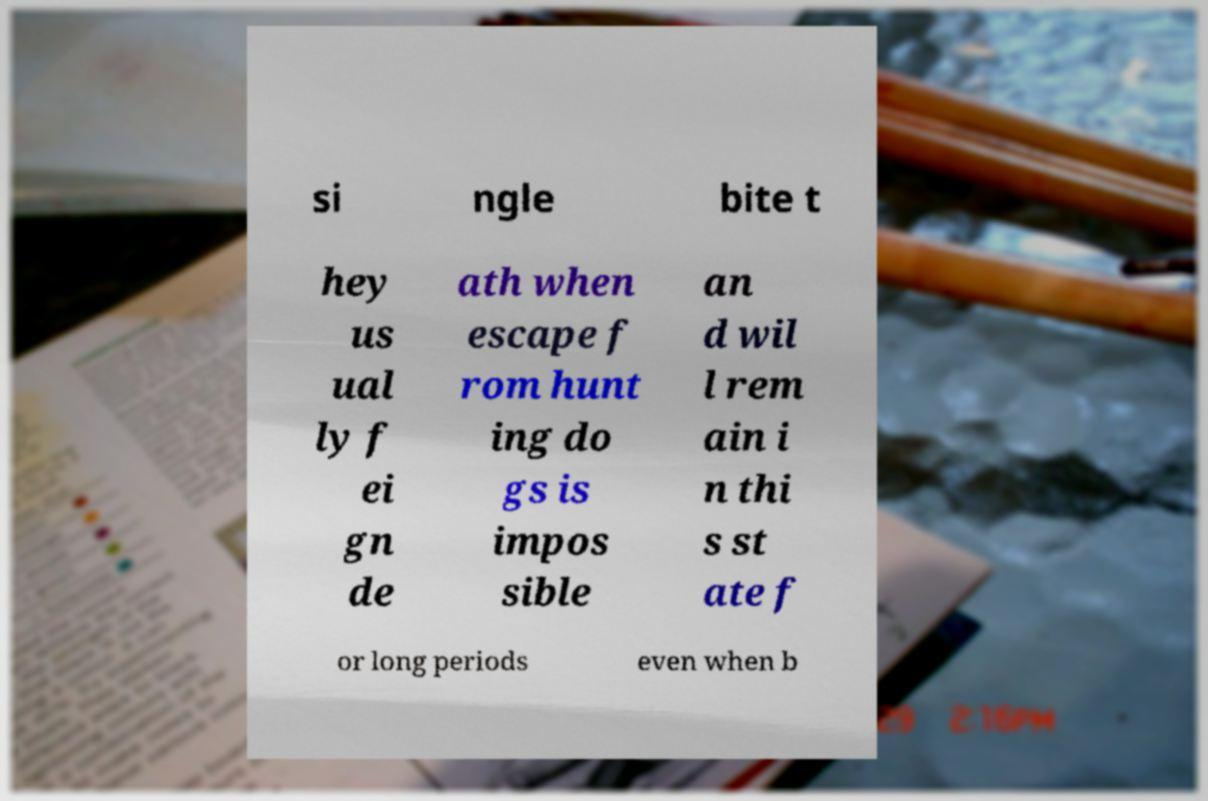For documentation purposes, I need the text within this image transcribed. Could you provide that? si ngle bite t hey us ual ly f ei gn de ath when escape f rom hunt ing do gs is impos sible an d wil l rem ain i n thi s st ate f or long periods even when b 